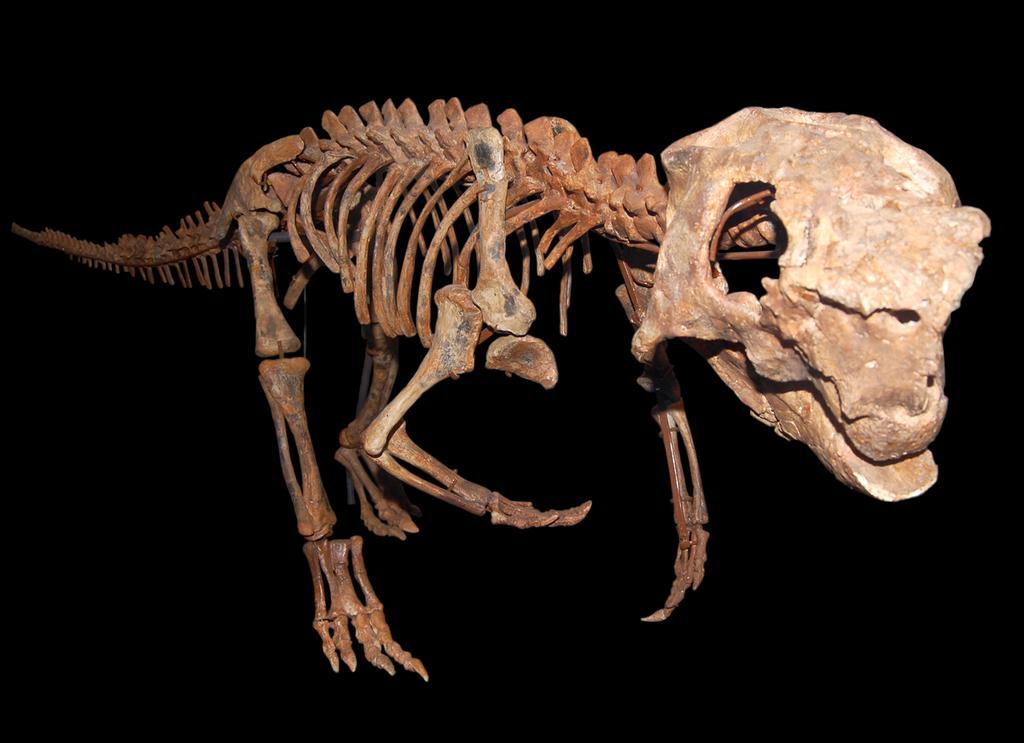Could you give a brief overview of what you see in this image? In this image I can see the skeleton of the animal which is in brown color and I can see the black background. 